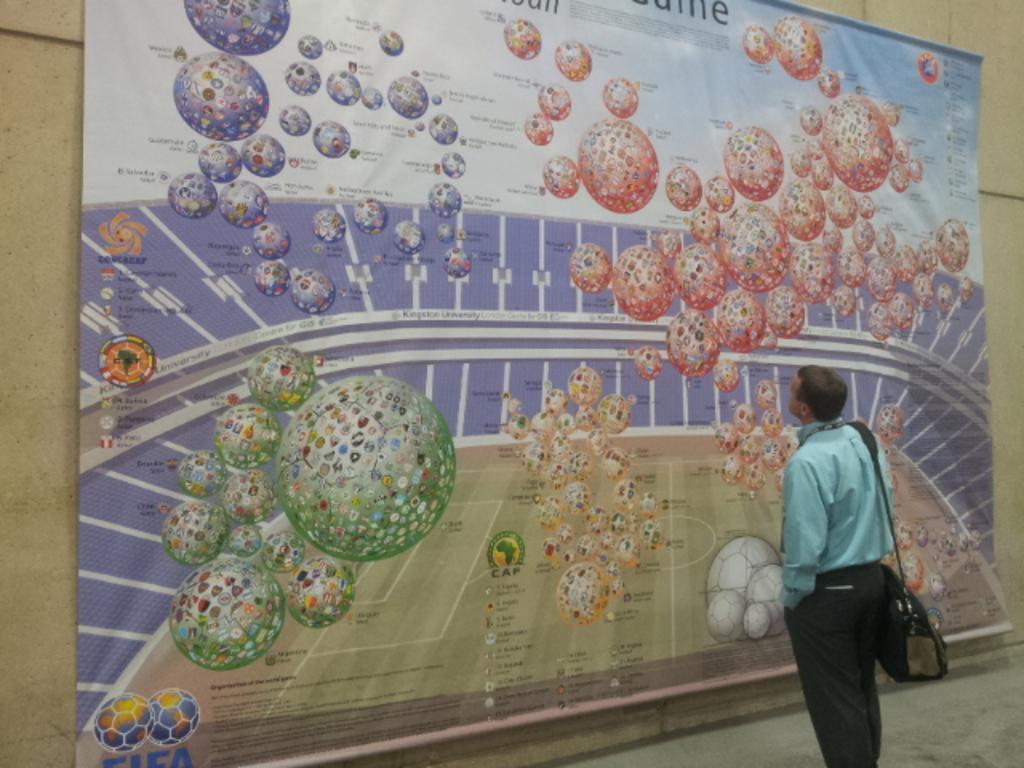Can you describe this image briefly? In the image there is a man in sea green shirt and bag standing and looking at the banner in front of the wall. 